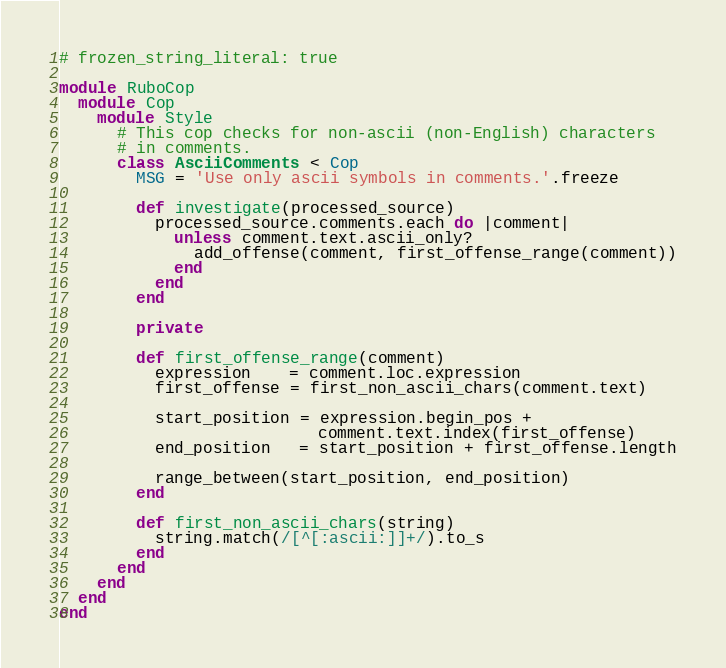<code> <loc_0><loc_0><loc_500><loc_500><_Ruby_># frozen_string_literal: true

module RuboCop
  module Cop
    module Style
      # This cop checks for non-ascii (non-English) characters
      # in comments.
      class AsciiComments < Cop
        MSG = 'Use only ascii symbols in comments.'.freeze

        def investigate(processed_source)
          processed_source.comments.each do |comment|
            unless comment.text.ascii_only?
              add_offense(comment, first_offense_range(comment))
            end
          end
        end

        private

        def first_offense_range(comment)
          expression    = comment.loc.expression
          first_offense = first_non_ascii_chars(comment.text)

          start_position = expression.begin_pos +
                           comment.text.index(first_offense)
          end_position   = start_position + first_offense.length

          range_between(start_position, end_position)
        end

        def first_non_ascii_chars(string)
          string.match(/[^[:ascii:]]+/).to_s
        end
      end
    end
  end
end
</code> 